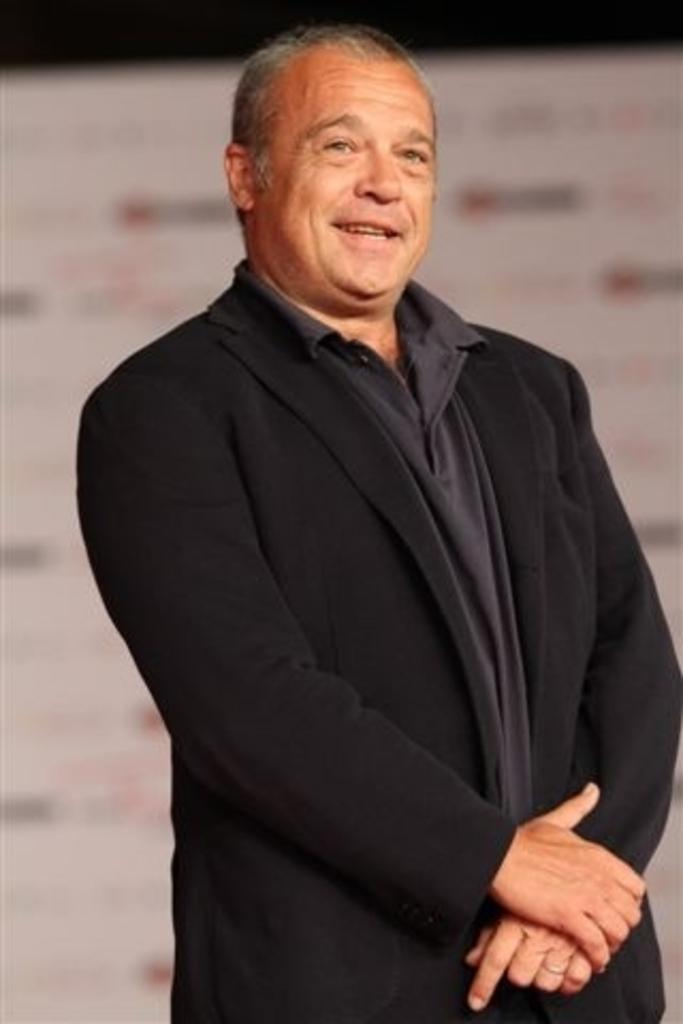What is the main subject of the image? There is a man in the image. What is the man wearing? The man is wearing a black suit. What is the man doing in the image? The man is standing and smiling. Can you describe the background of the image? The background of the image is blurred. How much salt is visible on the man's suit in the image? There is no salt visible on the man's suit in the image. Is the man walking through a rainstorm in the image? There is no rainstorm present in the image; the man is standing and smiling. 